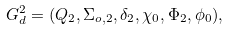Convert formula to latex. <formula><loc_0><loc_0><loc_500><loc_500>G _ { d } ^ { 2 } = ( Q _ { 2 } , \Sigma _ { o , 2 } , \delta _ { 2 } , \chi _ { 0 } , \Phi _ { 2 } , \phi _ { 0 } ) ,</formula> 